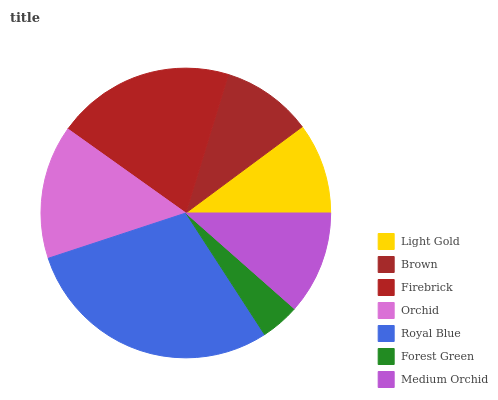Is Forest Green the minimum?
Answer yes or no. Yes. Is Royal Blue the maximum?
Answer yes or no. Yes. Is Brown the minimum?
Answer yes or no. No. Is Brown the maximum?
Answer yes or no. No. Is Light Gold greater than Brown?
Answer yes or no. Yes. Is Brown less than Light Gold?
Answer yes or no. Yes. Is Brown greater than Light Gold?
Answer yes or no. No. Is Light Gold less than Brown?
Answer yes or no. No. Is Medium Orchid the high median?
Answer yes or no. Yes. Is Medium Orchid the low median?
Answer yes or no. Yes. Is Forest Green the high median?
Answer yes or no. No. Is Brown the low median?
Answer yes or no. No. 